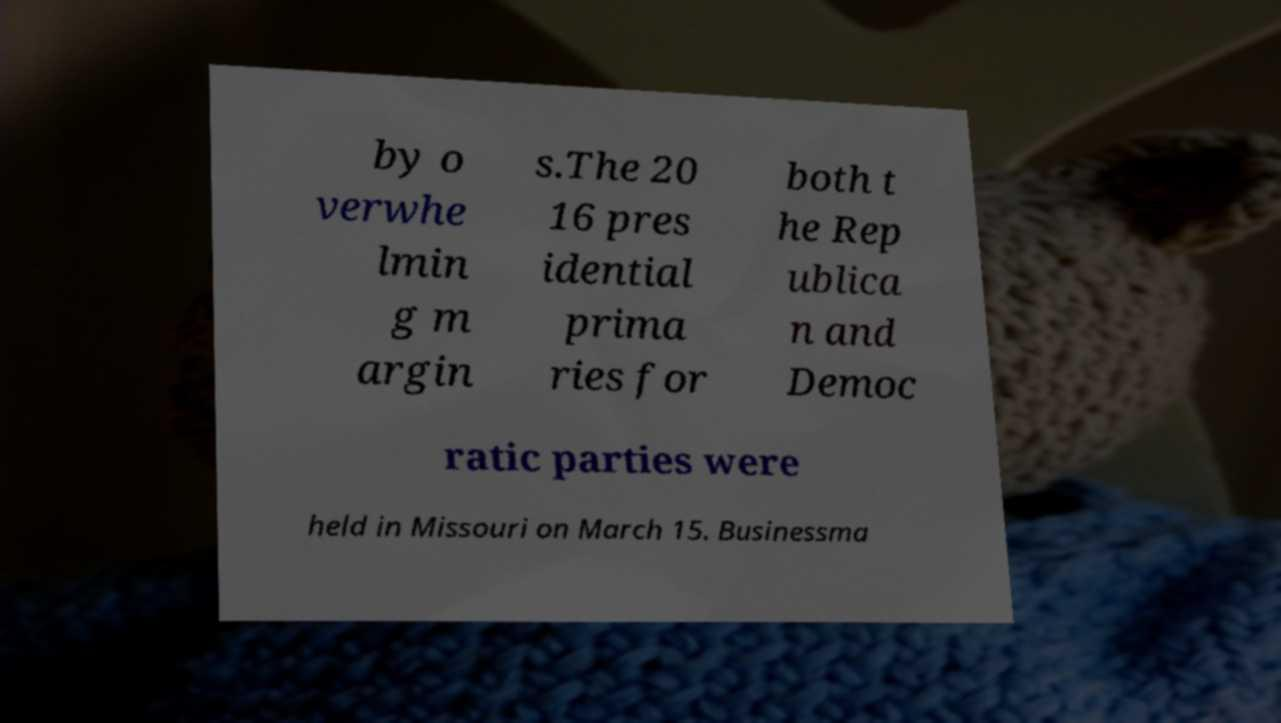There's text embedded in this image that I need extracted. Can you transcribe it verbatim? by o verwhe lmin g m argin s.The 20 16 pres idential prima ries for both t he Rep ublica n and Democ ratic parties were held in Missouri on March 15. Businessma 